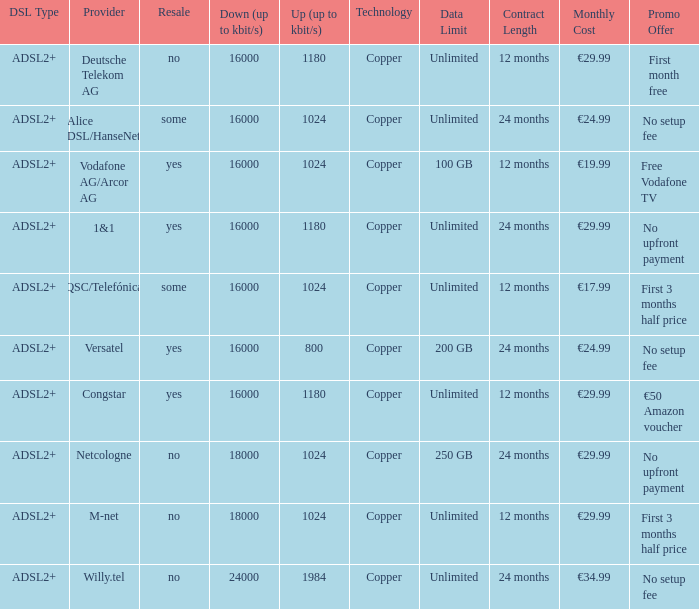Who are all of the telecom providers for which the upload rate is 1024 kbits and the resale category is yes? Vodafone AG/Arcor AG. 